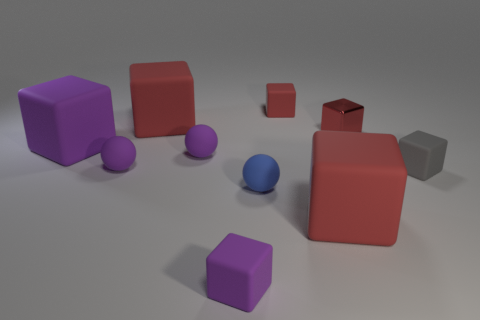There is a matte cube that is both to the right of the tiny purple block and behind the big purple object; what color is it?
Offer a very short reply. Red. What is the size of the metal thing that is the same shape as the small red matte thing?
Keep it short and to the point. Small. How many matte cubes are the same size as the metallic thing?
Your answer should be compact. 3. What is the material of the tiny gray object?
Make the answer very short. Rubber. There is a big purple object; are there any large things on the left side of it?
Ensure brevity in your answer.  No. There is a blue thing that is made of the same material as the big purple block; what size is it?
Offer a very short reply. Small. How many blocks are the same color as the shiny thing?
Your answer should be compact. 3. Is the number of small matte spheres that are in front of the blue thing less than the number of tiny purple matte spheres to the right of the gray rubber block?
Ensure brevity in your answer.  No. What is the size of the blue ball in front of the small gray cube?
Offer a very short reply. Small. Is there a object that has the same material as the large purple cube?
Your answer should be compact. Yes. 